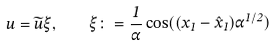<formula> <loc_0><loc_0><loc_500><loc_500>u = \widetilde { u } \xi , \quad \xi \colon = \frac { 1 } { \alpha } \cos ( ( x _ { 1 } - \hat { x } _ { 1 } ) \alpha ^ { 1 / 2 } )</formula> 